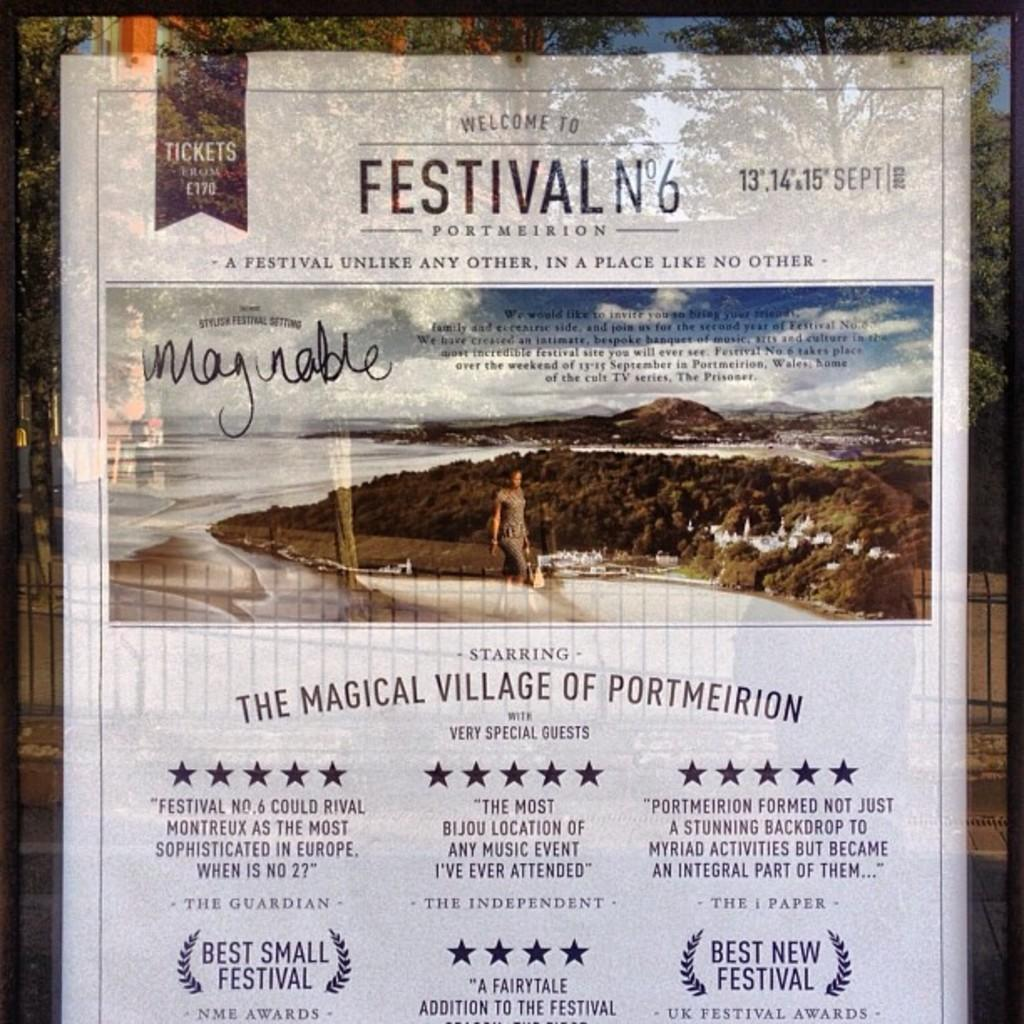Provide a one-sentence caption for the provided image. A white welcome poster of Festival N°6 show. 